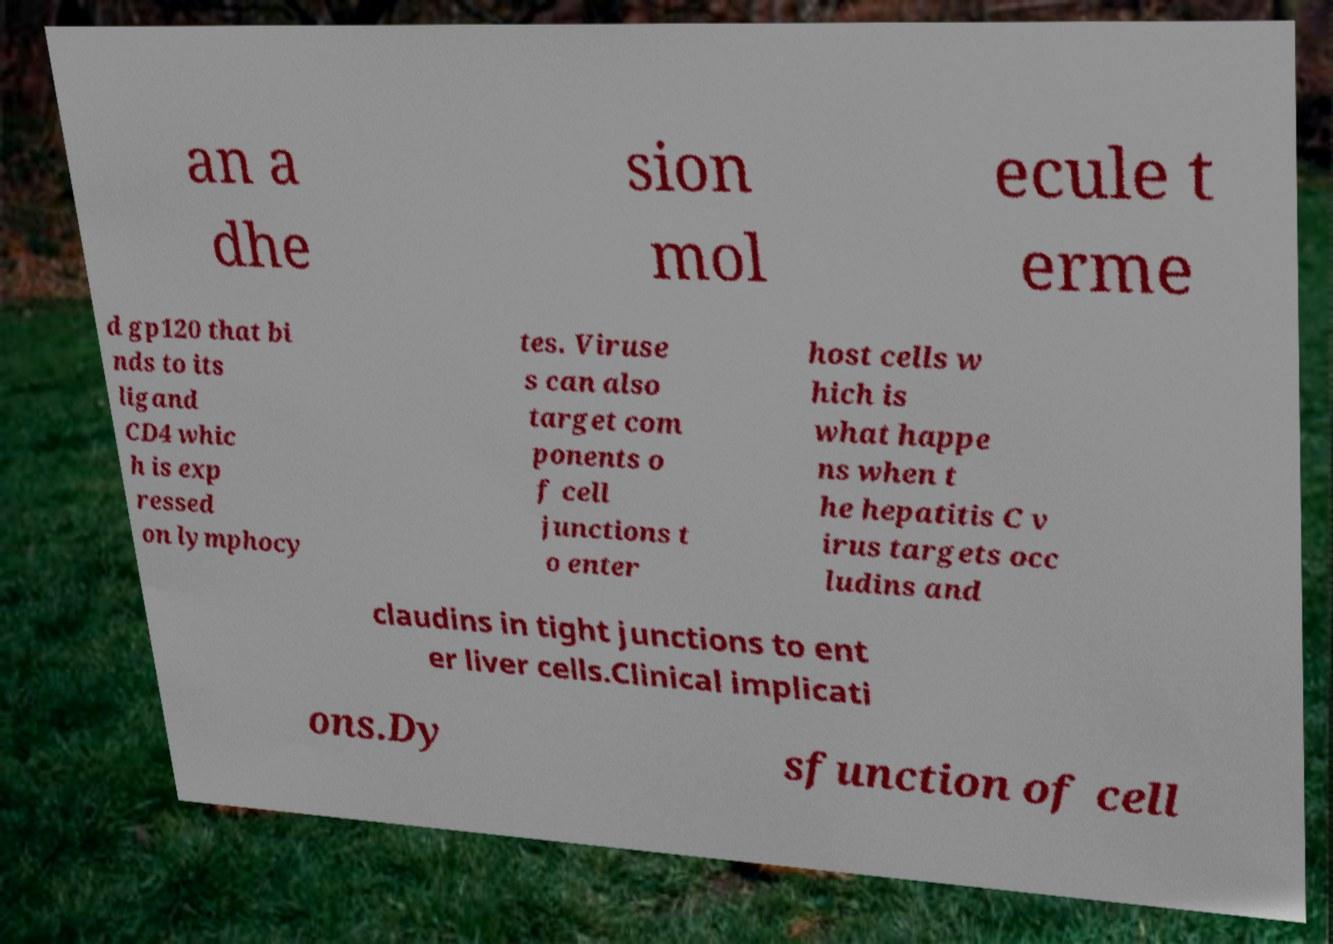Can you read and provide the text displayed in the image?This photo seems to have some interesting text. Can you extract and type it out for me? an a dhe sion mol ecule t erme d gp120 that bi nds to its ligand CD4 whic h is exp ressed on lymphocy tes. Viruse s can also target com ponents o f cell junctions t o enter host cells w hich is what happe ns when t he hepatitis C v irus targets occ ludins and claudins in tight junctions to ent er liver cells.Clinical implicati ons.Dy sfunction of cell 